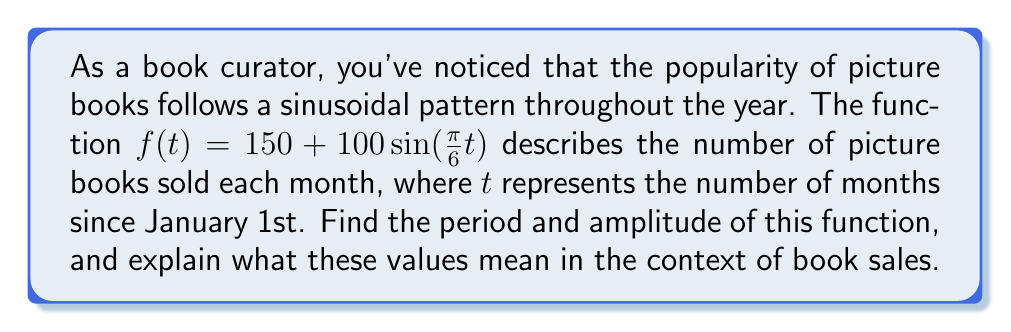What is the answer to this math problem? To find the period and amplitude of the given sinusoidal function, we need to analyze its components:

$f(t) = 150 + 100\sin(\frac{\pi}{6}t)$

1. Amplitude:
   The amplitude is the value that multiplies the sine function. In this case, it's 100.
   
   Amplitude = $|A| = |100| = 100$

   This means that the book sales fluctuate 100 units above and below the midline.

2. Period:
   For a sine function in the form $\sin(Bt)$, the period is given by $\frac{2\pi}{|B|}$.
   In our function, $B = \frac{\pi}{6}$

   Period = $\frac{2\pi}{|\frac{\pi}{6}|} = \frac{2\pi}{\frac{\pi}{6}} = 2 \cdot 6 = 12$

   This means that the sales pattern repeats every 12 months, or once a year.

In the context of book sales:
- The amplitude of 100 indicates that the number of picture books sold varies by 100 above and below the average (midline) of 150 books.
- The period of 12 months shows that this sales pattern completes one full cycle each year, likely due to seasonal factors affecting book-buying habits.
Answer: Amplitude: 100 books
Period: 12 months 